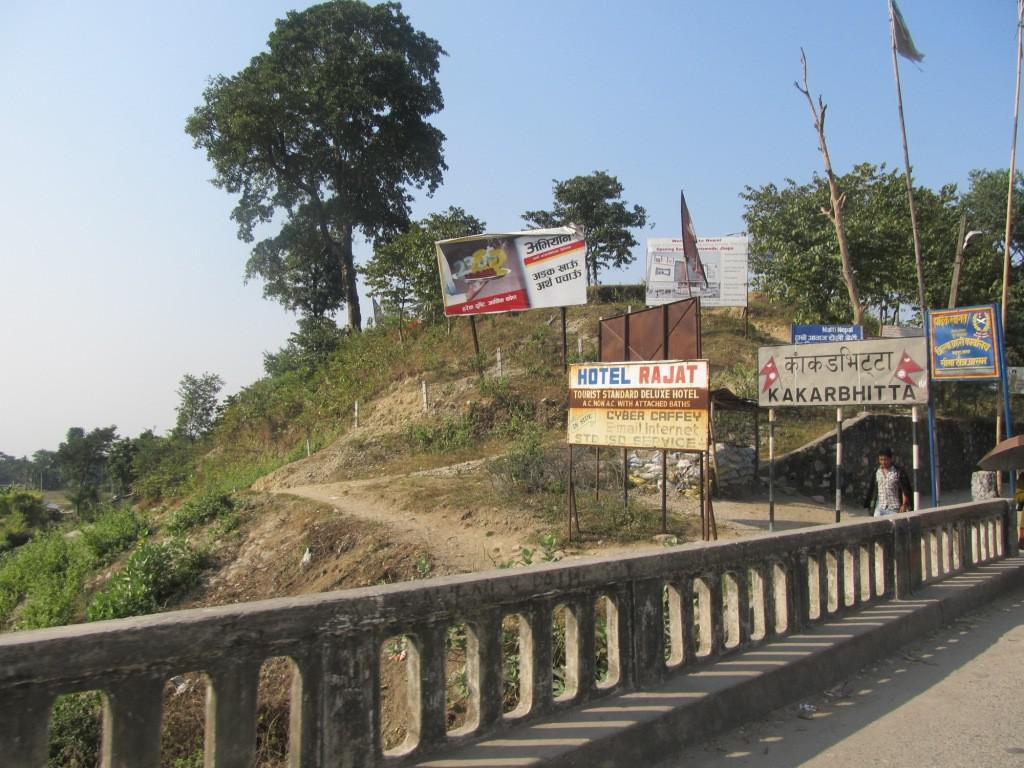<image>
Relay a brief, clear account of the picture shown. A sign for Hotel Rajat has blue and red letters on it. 